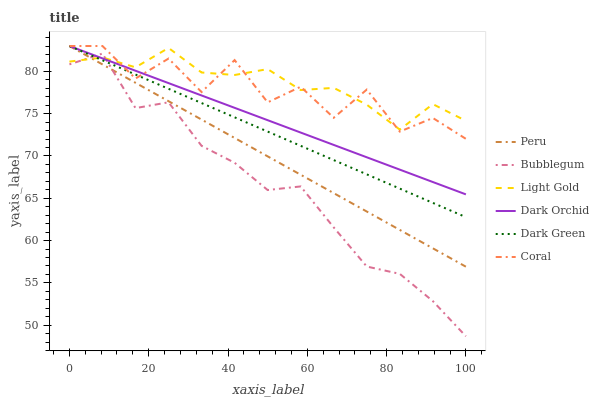Does Dark Orchid have the minimum area under the curve?
Answer yes or no. No. Does Dark Orchid have the maximum area under the curve?
Answer yes or no. No. Is Dark Orchid the smoothest?
Answer yes or no. No. Is Dark Orchid the roughest?
Answer yes or no. No. Does Dark Orchid have the lowest value?
Answer yes or no. No. Does Bubblegum have the highest value?
Answer yes or no. No. Is Bubblegum less than Coral?
Answer yes or no. Yes. Is Coral greater than Bubblegum?
Answer yes or no. Yes. Does Bubblegum intersect Coral?
Answer yes or no. No. 